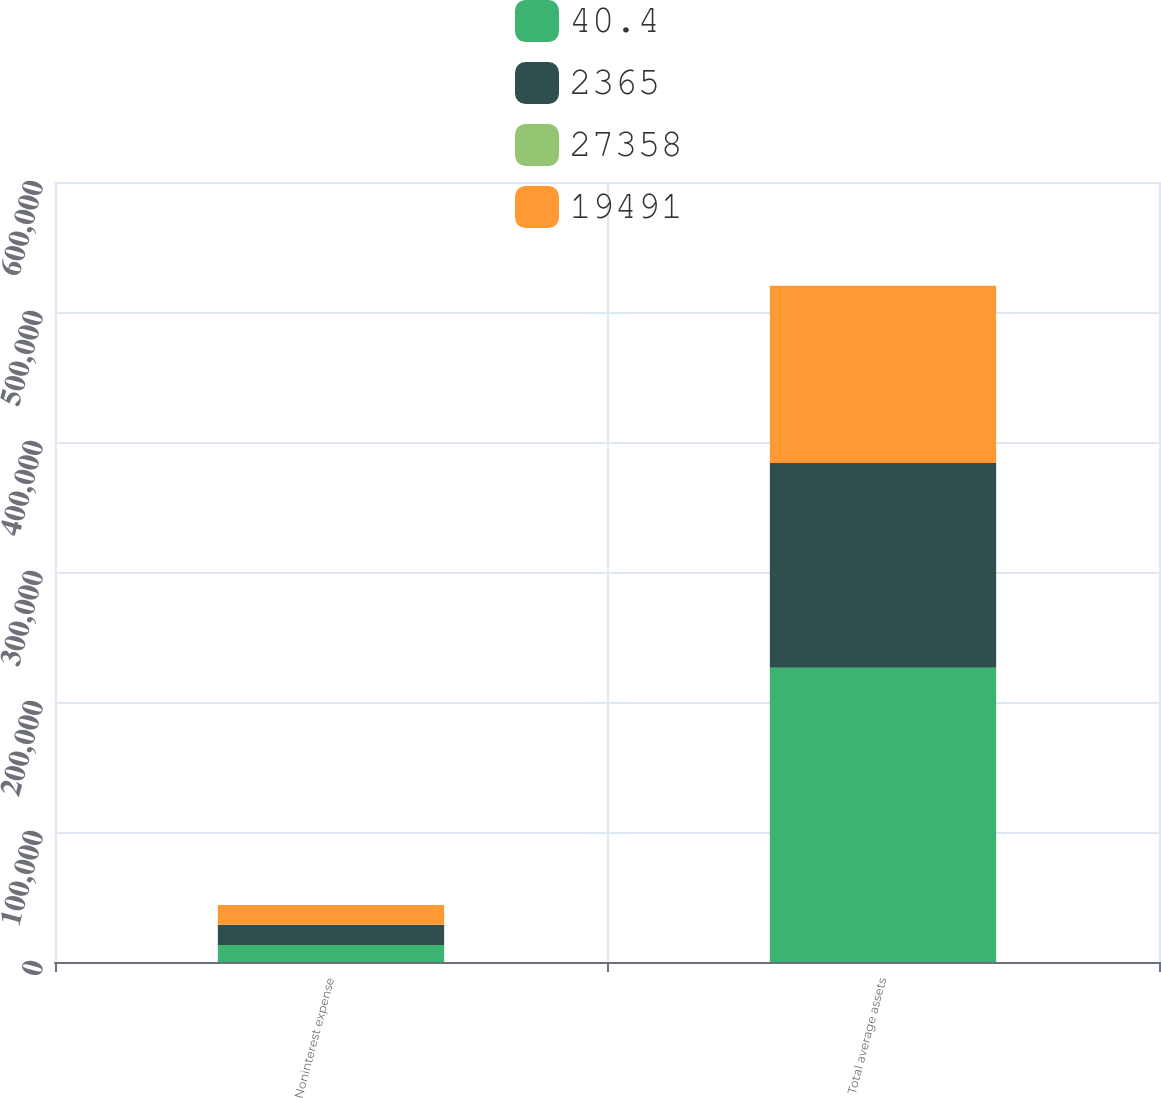Convert chart. <chart><loc_0><loc_0><loc_500><loc_500><stacked_bar_chart><ecel><fcel>Noninterest expense<fcel>Total average assets<nl><fcel>40.4<fcel>13079<fcel>226423<nl><fcel>2365<fcel>15652<fcel>157461<nl><fcel>27358<fcel>16.4<fcel>43.8<nl><fcel>19491<fcel>15140<fcel>136176<nl></chart> 